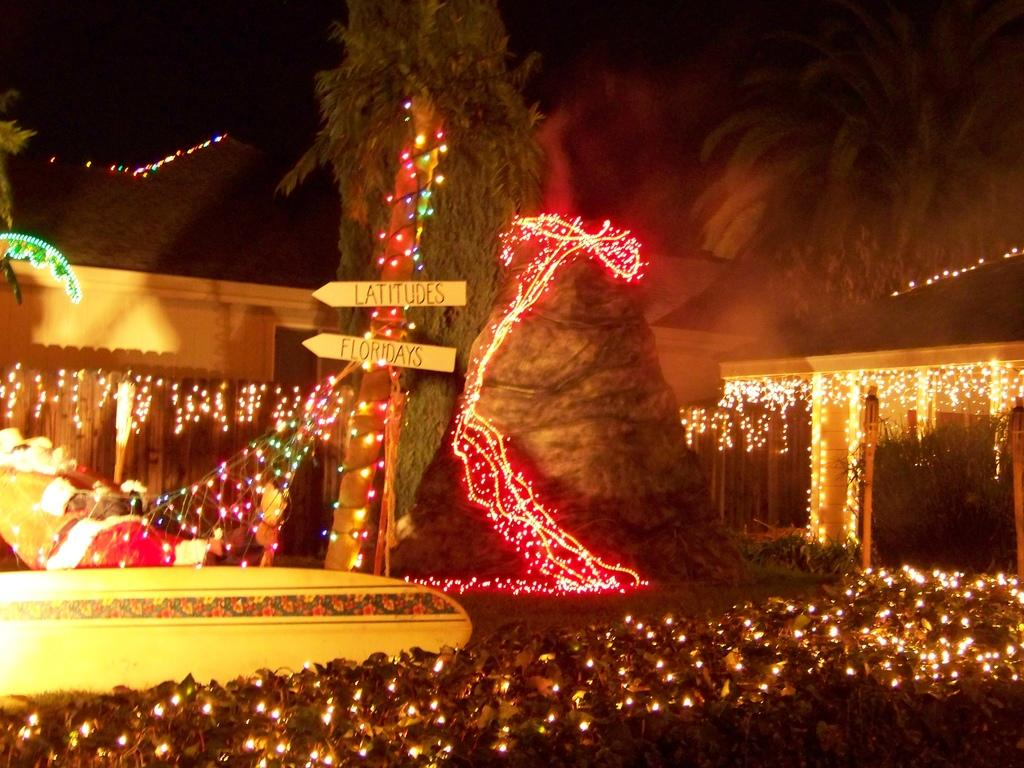What is located in the center of the image? There are trees in the center of the image. What can be seen in the image besides the trees? There are lights and bushes visible in the image. What structure is present in the background of the image? There is a shed in the background of the image. What is visible at the top of the image? The sky is visible at the top of the image. What type of flowers are in the jar on the left side of the image? There is no jar or flowers present in the image. Who is the representative of the group in the image? There is no group or representative depicted in the image. 